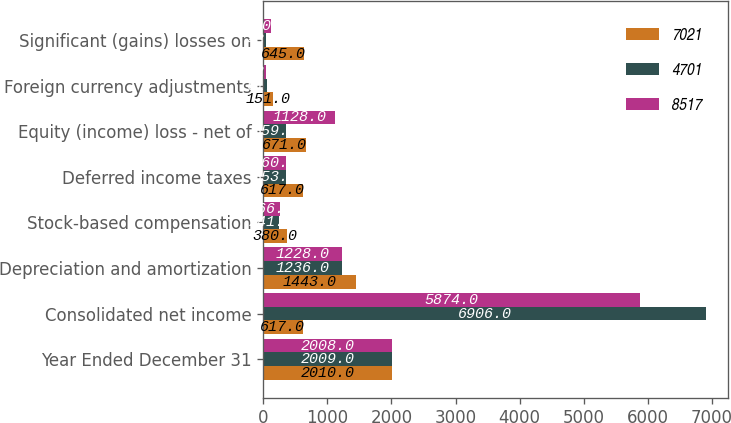Convert chart to OTSL. <chart><loc_0><loc_0><loc_500><loc_500><stacked_bar_chart><ecel><fcel>Year Ended December 31<fcel>Consolidated net income<fcel>Depreciation and amortization<fcel>Stock-based compensation<fcel>Deferred income taxes<fcel>Equity (income) loss - net of<fcel>Foreign currency adjustments<fcel>Significant (gains) losses on<nl><fcel>7021<fcel>2010<fcel>617<fcel>1443<fcel>380<fcel>617<fcel>671<fcel>151<fcel>645<nl><fcel>4701<fcel>2009<fcel>6906<fcel>1236<fcel>241<fcel>353<fcel>359<fcel>61<fcel>43<nl><fcel>8517<fcel>2008<fcel>5874<fcel>1228<fcel>266<fcel>360<fcel>1128<fcel>42<fcel>130<nl></chart> 